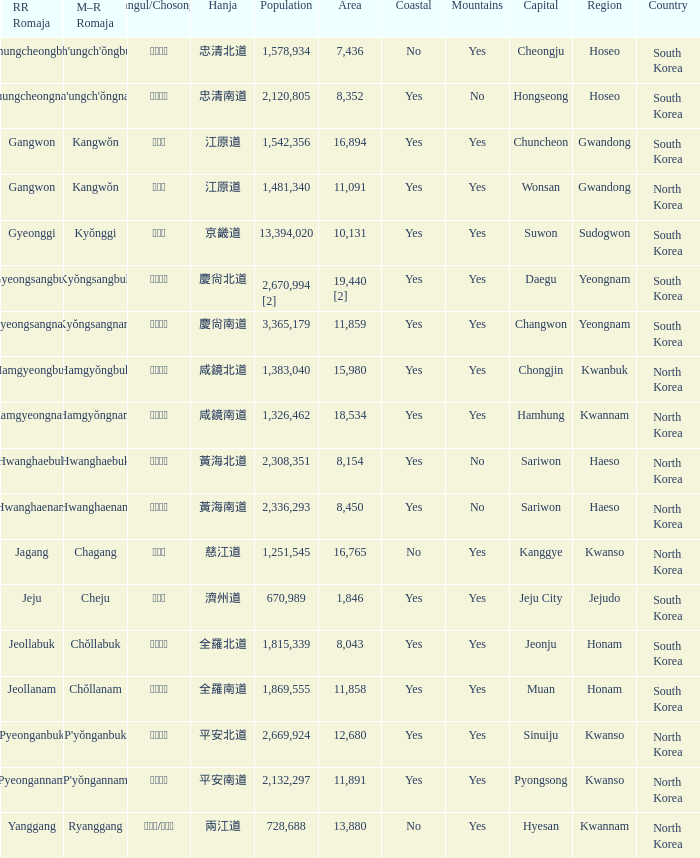Can you give me this table as a dict? {'header': ['RR Romaja', 'M–R Romaja', 'Hangul/Chosongul', 'Hanja', 'Population', 'Area', 'Coastal', 'Mountains', 'Capital', 'Region', 'Country'], 'rows': [['Chungcheongbuk', "Ch'ungch'ŏngbuk", '충청북도', '忠清北道', '1,578,934', '7,436', 'No', 'Yes', 'Cheongju', 'Hoseo', 'South Korea'], ['Chungcheongnam', "Ch'ungch'ŏngnam", '충청남도', '忠清南道', '2,120,805', '8,352', 'Yes', 'No', 'Hongseong', 'Hoseo', 'South Korea'], ['Gangwon', 'Kangwŏn', '강원도', '江原道', '1,542,356', '16,894', 'Yes', 'Yes', 'Chuncheon', 'Gwandong', 'South Korea'], ['Gangwon', 'Kangwŏn', '강원도', '江原道', '1,481,340', '11,091', 'Yes', 'Yes', 'Wonsan', 'Gwandong', 'North Korea'], ['Gyeonggi', 'Kyŏnggi', '경기도', '京畿道', '13,394,020', '10,131', 'Yes', 'Yes', 'Suwon', 'Sudogwon', 'South Korea'], ['Gyeongsangbuk', 'Kyŏngsangbuk', '경상북도', '慶尙北道', '2,670,994 [2]', '19,440 [2]', 'Yes', 'Yes', 'Daegu', 'Yeongnam', 'South Korea'], ['Gyeongsangnam', 'Kyŏngsangnam', '경상남도', '慶尙南道', '3,365,179', '11,859', 'Yes', 'Yes', 'Changwon', 'Yeongnam', 'South Korea'], ['Hamgyeongbuk', 'Hamgyŏngbuk', '함경북도', '咸鏡北道', '1,383,040', '15,980', 'Yes', 'Yes', 'Chongjin', 'Kwanbuk', 'North Korea'], ['Hamgyeongnam', 'Hamgyŏngnam', '함경남도', '咸鏡南道', '1,326,462', '18,534', 'Yes', 'Yes', 'Hamhung', 'Kwannam', 'North Korea'], ['Hwanghaebuk', 'Hwanghaebuk', '황해북도', '黃海北道', '2,308,351', '8,154', 'Yes', 'No', 'Sariwon', 'Haeso', 'North Korea'], ['Hwanghaenam', 'Hwanghaenam', '황해남도', '黃海南道', '2,336,293', '8,450', 'Yes', 'No', 'Sariwon', 'Haeso', 'North Korea'], ['Jagang', 'Chagang', '자강도', '慈江道', '1,251,545', '16,765', 'No', 'Yes', 'Kanggye', 'Kwanso', 'North Korea'], ['Jeju', 'Cheju', '제주도', '濟州道', '670,989', '1,846', 'Yes', 'Yes', 'Jeju City', 'Jejudo', 'South Korea'], ['Jeollabuk', 'Chŏllabuk', '전라북도', '全羅北道', '1,815,339', '8,043', 'Yes', 'Yes', 'Jeonju', 'Honam', 'South Korea'], ['Jeollanam', 'Chŏllanam', '전라남도', '全羅南道', '1,869,555', '11,858', 'Yes', 'Yes', 'Muan', 'Honam', 'South Korea'], ['Pyeonganbuk', "P'yŏnganbuk", '평안북도', '平安北道', '2,669,924', '12,680', 'Yes', 'Yes', 'Sinuiju', 'Kwanso', 'North Korea'], ['Pyeongannam', "P'yŏngannam", '평안남도', '平安南道', '2,132,297', '11,891', 'Yes', 'Yes', 'Pyongsong', 'Kwanso', 'North Korea'], ['Yanggang', 'Ryanggang', '량강도/양강도', '兩江道', '728,688', '13,880', 'No', 'Yes', 'Hyesan', 'Kwannam', 'North Korea']]} What is the RR Romaja for the province that has Hangul of 강원도 and capital of Wonsan? Gangwon. 